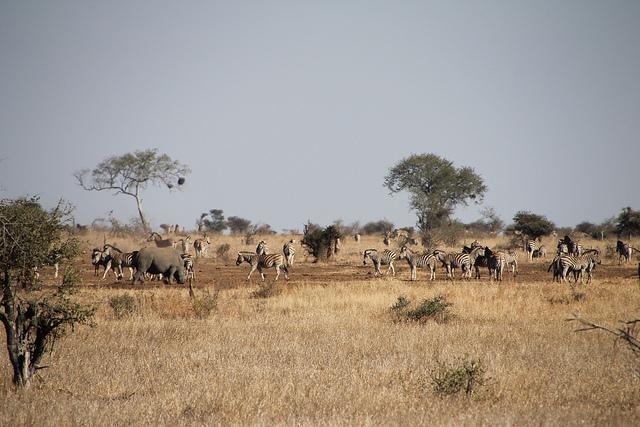How many apple brand laptops can you see?
Give a very brief answer. 0. 